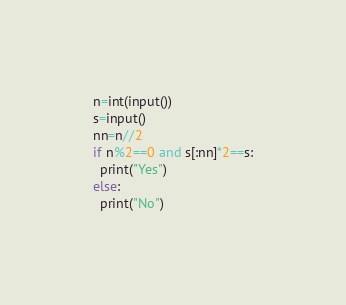Convert code to text. <code><loc_0><loc_0><loc_500><loc_500><_Python_>n=int(input())
s=input()
nn=n//2
if n%2==0 and s[:nn]*2==s:
  print("Yes")
else:
  print("No")</code> 